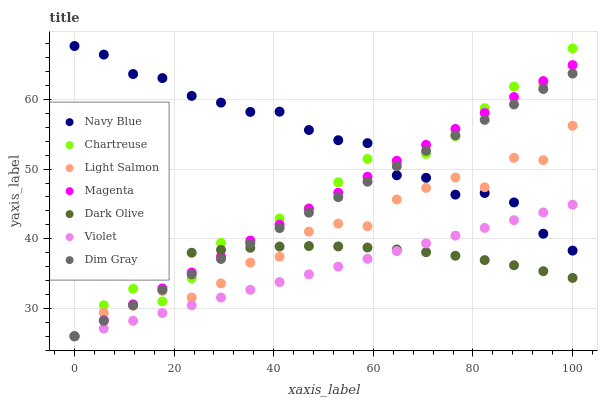Does Violet have the minimum area under the curve?
Answer yes or no. Yes. Does Navy Blue have the maximum area under the curve?
Answer yes or no. Yes. Does Dim Gray have the minimum area under the curve?
Answer yes or no. No. Does Dim Gray have the maximum area under the curve?
Answer yes or no. No. Is Violet the smoothest?
Answer yes or no. Yes. Is Light Salmon the roughest?
Answer yes or no. Yes. Is Dim Gray the smoothest?
Answer yes or no. No. Is Dim Gray the roughest?
Answer yes or no. No. Does Light Salmon have the lowest value?
Answer yes or no. Yes. Does Navy Blue have the lowest value?
Answer yes or no. No. Does Navy Blue have the highest value?
Answer yes or no. Yes. Does Dim Gray have the highest value?
Answer yes or no. No. Is Dark Olive less than Navy Blue?
Answer yes or no. Yes. Is Navy Blue greater than Dark Olive?
Answer yes or no. Yes. Does Navy Blue intersect Light Salmon?
Answer yes or no. Yes. Is Navy Blue less than Light Salmon?
Answer yes or no. No. Is Navy Blue greater than Light Salmon?
Answer yes or no. No. Does Dark Olive intersect Navy Blue?
Answer yes or no. No. 